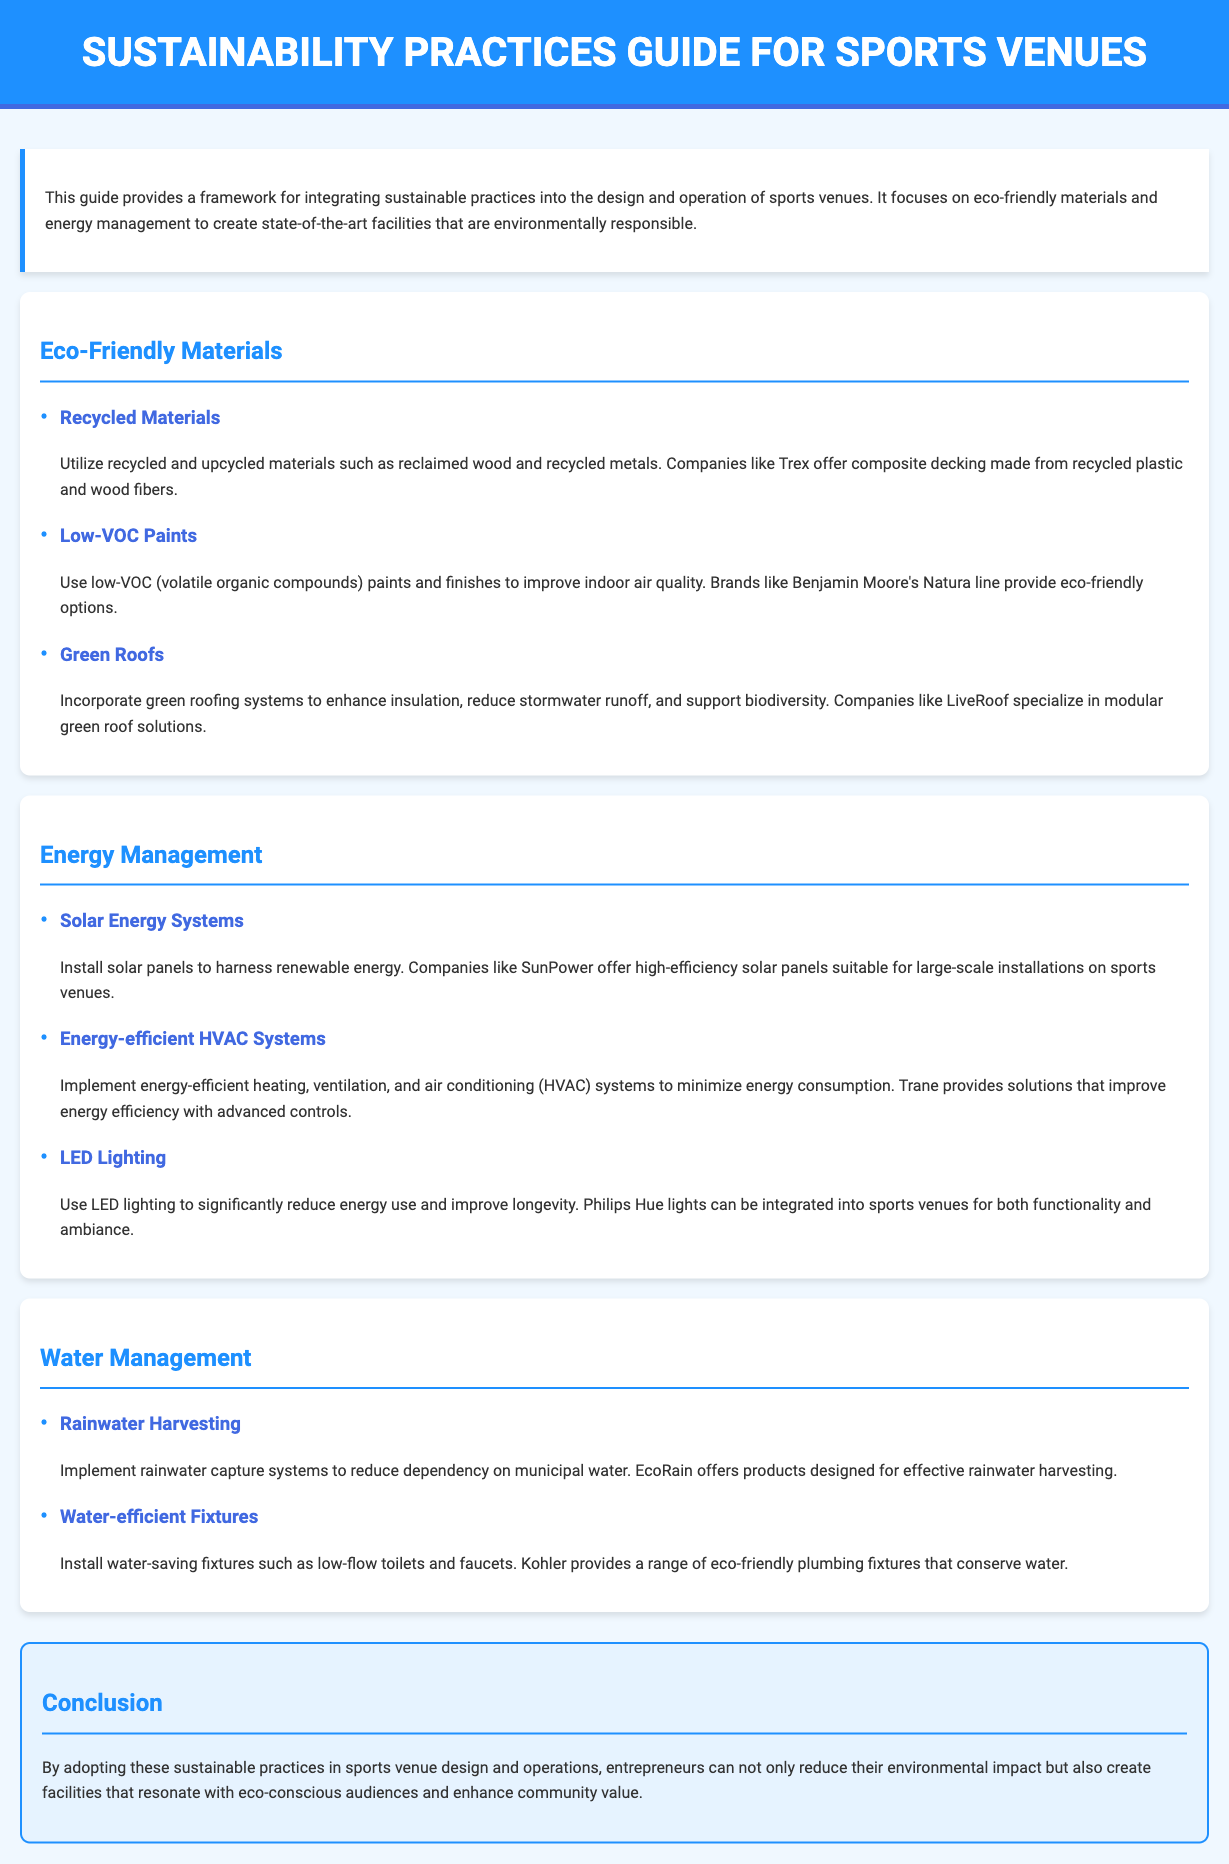What does this guide focus on? The guide focuses on integrating sustainable practices into the design and operation of sports venues, specifically eco-friendly materials and energy management.
Answer: Sustainable practices What company offers composite decking? Trex is mentioned in the document as a company that offers composite decking made from recycled plastic and wood fibers.
Answer: Trex What material is used in low-VOC paints? The document refers to low-VOC paints and specifically mentions Benjamin Moore's Natura line as an eco-friendly option.
Answer: Benjamin Moore's Natura What type of roofing system can enhance insulation? The guide suggests incorporating green roofing systems to enhance insulation and reduce stormwater runoff.
Answer: Green roofs What is a potential benefit of using solar panels? The document states that installing solar panels can harness renewable energy, providing a sustainable option for energy management.
Answer: Renewable energy Which company provides energy-efficient HVAC systems? Trane is listed in the document as a company that provides energy-efficient HVAC solutions that improve energy efficiency.
Answer: Trane What fixtures can help conserve water? The document notes the installation of low-flow toilets and faucets as water-saving fixtures to conserve water.
Answer: Low-flow toilets and faucets Why should venues adopt sustainable practices? The conclusion emphasizes that adopting sustainable practices can reduce environmental impact and resonate with eco-conscious audiences.
Answer: Reduce environmental impact What type of lighting is recommended? The document recommends using LED lighting to significantly reduce energy use and improve longevity.
Answer: LED lighting 